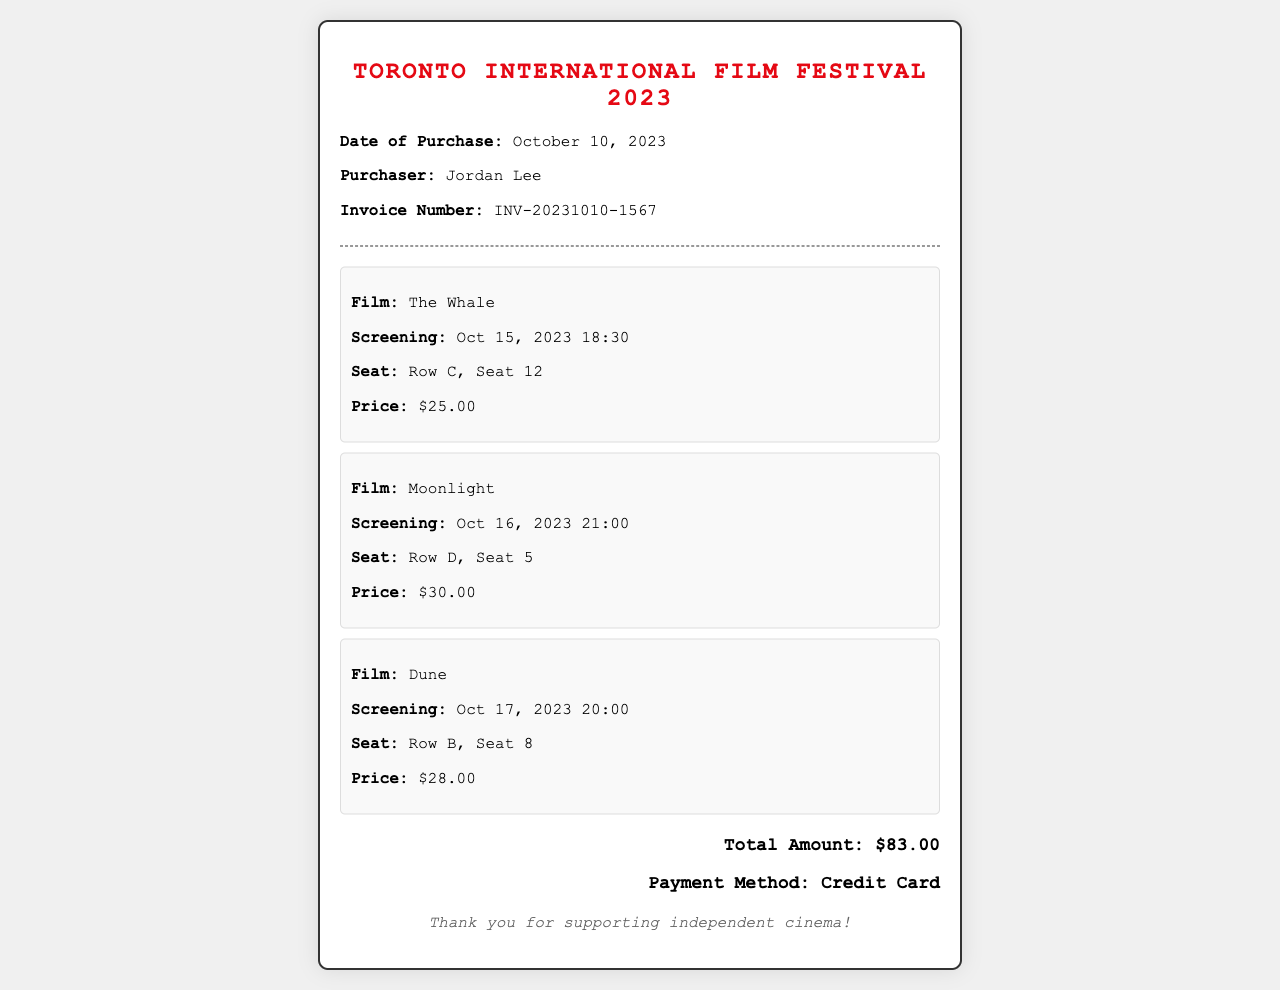What is the date of purchase? The date of purchase is explicitly stated in the document.
Answer: October 10, 2023 Who is the purchaser? The purchaser's name is mentioned in the document.
Answer: Jordan Lee What is the invoice number? The invoice number is noted on the receipt for reference.
Answer: INV-20231010-1567 What is the price of the ticket for "The Whale"? The price for "The Whale" ticket is specified in the ticket section.
Answer: $25.00 Which film is scheduled for screening on October 17, 2023? The document lists the screenings along with their respective dates.
Answer: Dune How many tickets were purchased in total? The document lists three individual tickets, thus the total number is calculated by counting them.
Answer: 3 What is the total amount paid? The total amount paid is provided at the bottom of the receipt.
Answer: $83.00 What payment method was used? The payment method is stated clearly in the receipt.
Answer: Credit Card What is the seat number for "Moonlight"? The seat number for "Moonlight" is specified in the respective ticket information.
Answer: Row D, Seat 5 